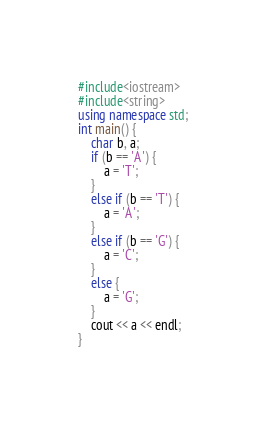<code> <loc_0><loc_0><loc_500><loc_500><_C++_>#include<iostream>
#include<string>
using namespace std;
int main() {
	char b, a;
	if (b == 'A') {
		a = 'T';
	}
	else if (b == 'T') {
		a = 'A';
	}
	else if (b == 'G') {
		a = 'C';
	}
	else {
		a = 'G';
	}
	cout << a << endl;
}</code> 